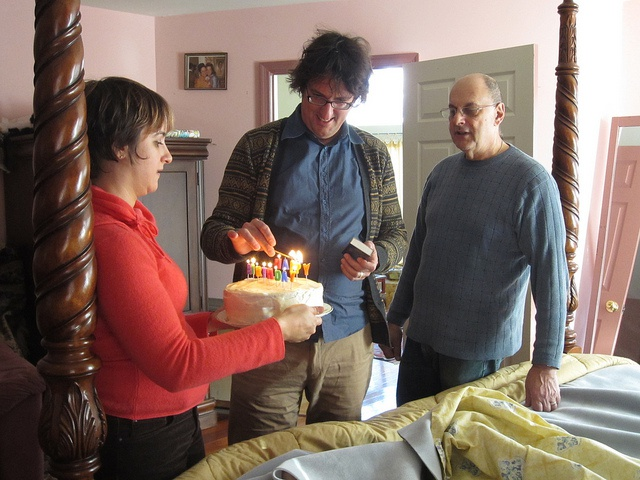Describe the objects in this image and their specific colors. I can see people in darkgray, black, gray, and maroon tones, people in darkgray, black, maroon, brown, and red tones, people in darkgray, black, and gray tones, bed in darkgray, olive, ivory, and gray tones, and tv in darkgray, gray, and black tones in this image. 